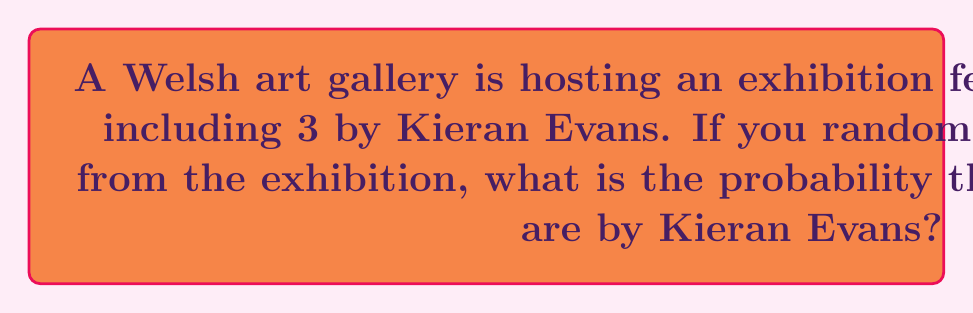Can you solve this math problem? Let's approach this step-by-step using the concept of combinations:

1) First, we need to calculate the total number of ways to select 5 paintings out of 20. This is given by the combination formula:

   $$\binom{20}{5} = \frac{20!}{5!(20-5)!} = \frac{20!}{5!15!} = 15504$$

2) Now, we need to calculate the number of ways to select exactly 2 Kieran Evans paintings and 3 non-Kieran Evans paintings:

   - Ways to select 2 Kieran Evans paintings out of 3: $\binom{3}{2} = 3$
   - Ways to select 3 non-Kieran Evans paintings out of 17: $\binom{17}{3} = 680$

3) The total number of favorable outcomes is the product of these:

   $$3 \times 680 = 2040$$

4) The probability is then the number of favorable outcomes divided by the total number of possible outcomes:

   $$P(\text{exactly 2 Kieran Evans paintings}) = \frac{2040}{15504} = \frac{255}{1938} \approx 0.1316$$
Answer: $\frac{255}{1938}$ 